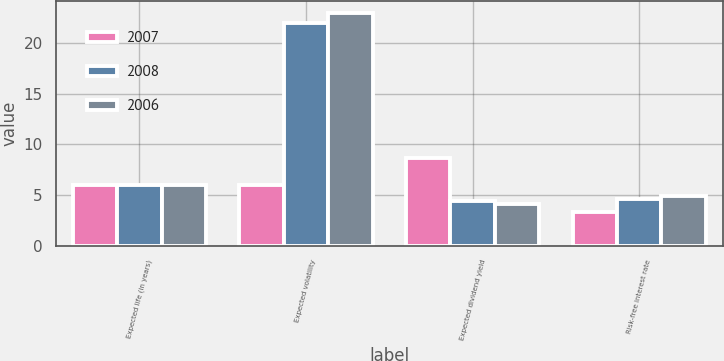Convert chart to OTSL. <chart><loc_0><loc_0><loc_500><loc_500><stacked_bar_chart><ecel><fcel>Expected life (in years)<fcel>Expected volatility<fcel>Expected dividend yield<fcel>Risk-free interest rate<nl><fcel>2007<fcel>6<fcel>6<fcel>8.7<fcel>3.3<nl><fcel>2008<fcel>6<fcel>22<fcel>4.4<fcel>4.6<nl><fcel>2006<fcel>6<fcel>23<fcel>4.1<fcel>4.9<nl></chart> 